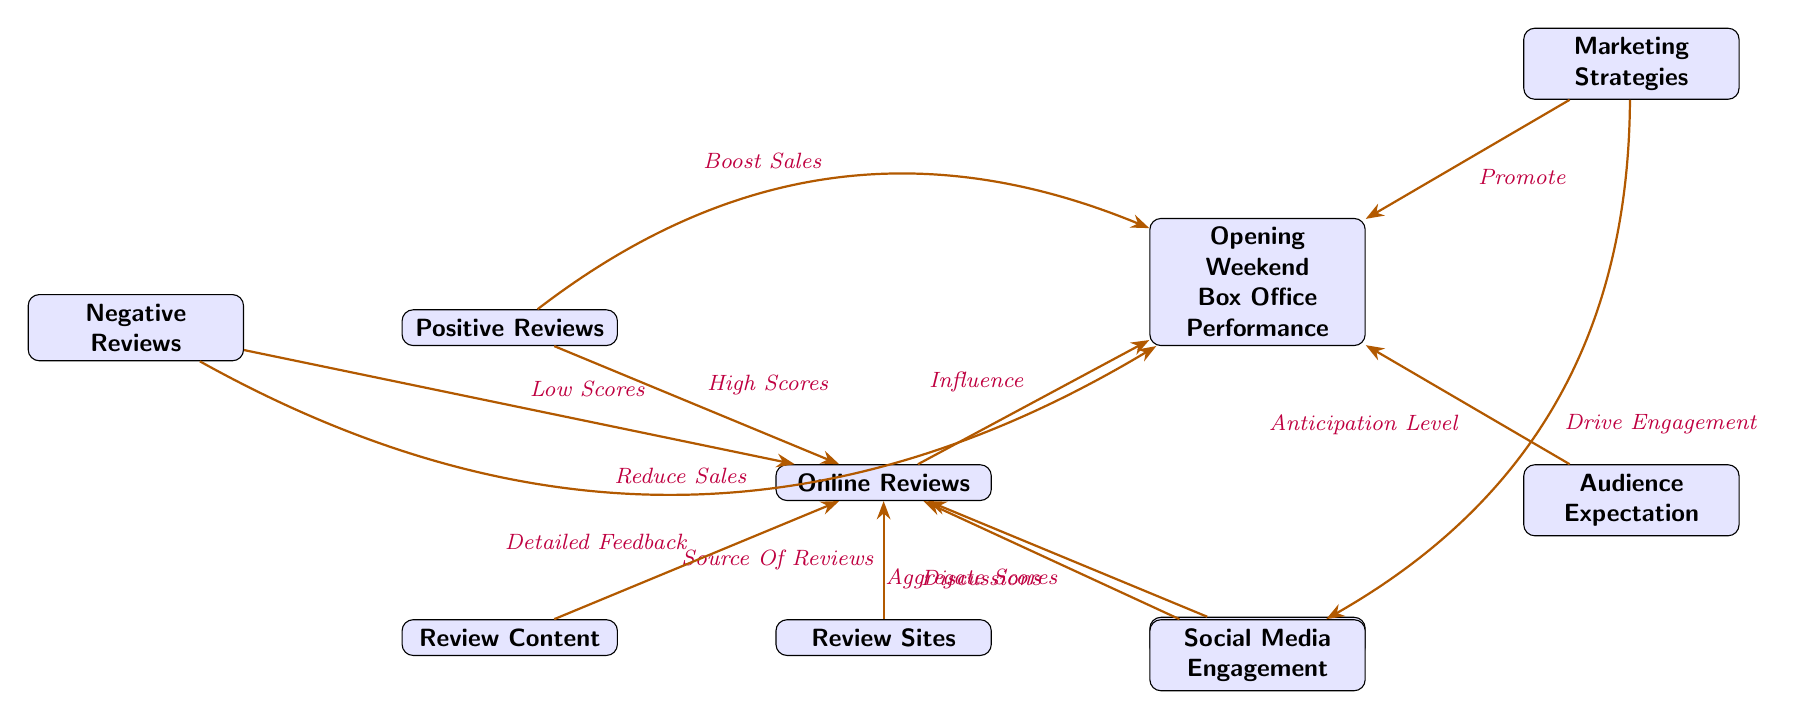What is the main outcome of the diagram? The center node, which is "Opening Weekend Box Office Performance," indicates that the main outcome of the diagram is the performance at the box office during the opening weekend.
Answer: Opening Weekend Box Office Performance How many nodes are in the left section of the diagram? The left section includes "Online Reviews," "Review Sites," "Review Content," "Negative Reviews," and "Positive Reviews," totaling five nodes.
Answer: 5 What influences online reviews according to the diagram? The arrows directed toward "Online Reviews" indicate that influences include "Review Sites," "Review Content," "Ratings," "Social Media Engagement," "Negative Reviews," and "Positive Reviews."
Answer: Review Sites, Review Content, Ratings, Social Media Engagement, Negative Reviews, Positive Reviews What effect do positive reviews have on box office performance? The diagram shows an arrow from "Positive Reviews" to "Opening Weekend Box Office Performance" indicating that positive reviews lead to a boost in sales.
Answer: Boost Sales What is the relationship between social media and box office performance? The diagram illustrates that "Social Media Engagement" influences "Online Reviews," which in turn influences "Opening Weekend Box Office Performance." The connection suggests social media plays a role in reviewing and thus affects box office outcomes.
Answer: Influence through Online Reviews Which node is directly influenced by audience expectation? The diagram shows a direct arrow from "Audience Expectation" pointing to "Opening Weekend Box Office Performance," indicating that audience expectation directly affects the box office performance.
Answer: Opening Weekend Box Office Performance What type of marketing strategy is linked to driving engagement in social media? The diagram connects "Marketing Strategies" to "Social Media Engagement" with an arrow indicating that marketing strategies drive engagement on social media platforms.
Answer: Drive Engagement Which type of reviews are indicated to lower sales? The diagram clearly depicts that "Negative Reviews" have an arrow pointing to "Opening Weekend Box Office Performance," with the description "Reduce Sales," indicating their negative impact on box office performance.
Answer: Negative Reviews 